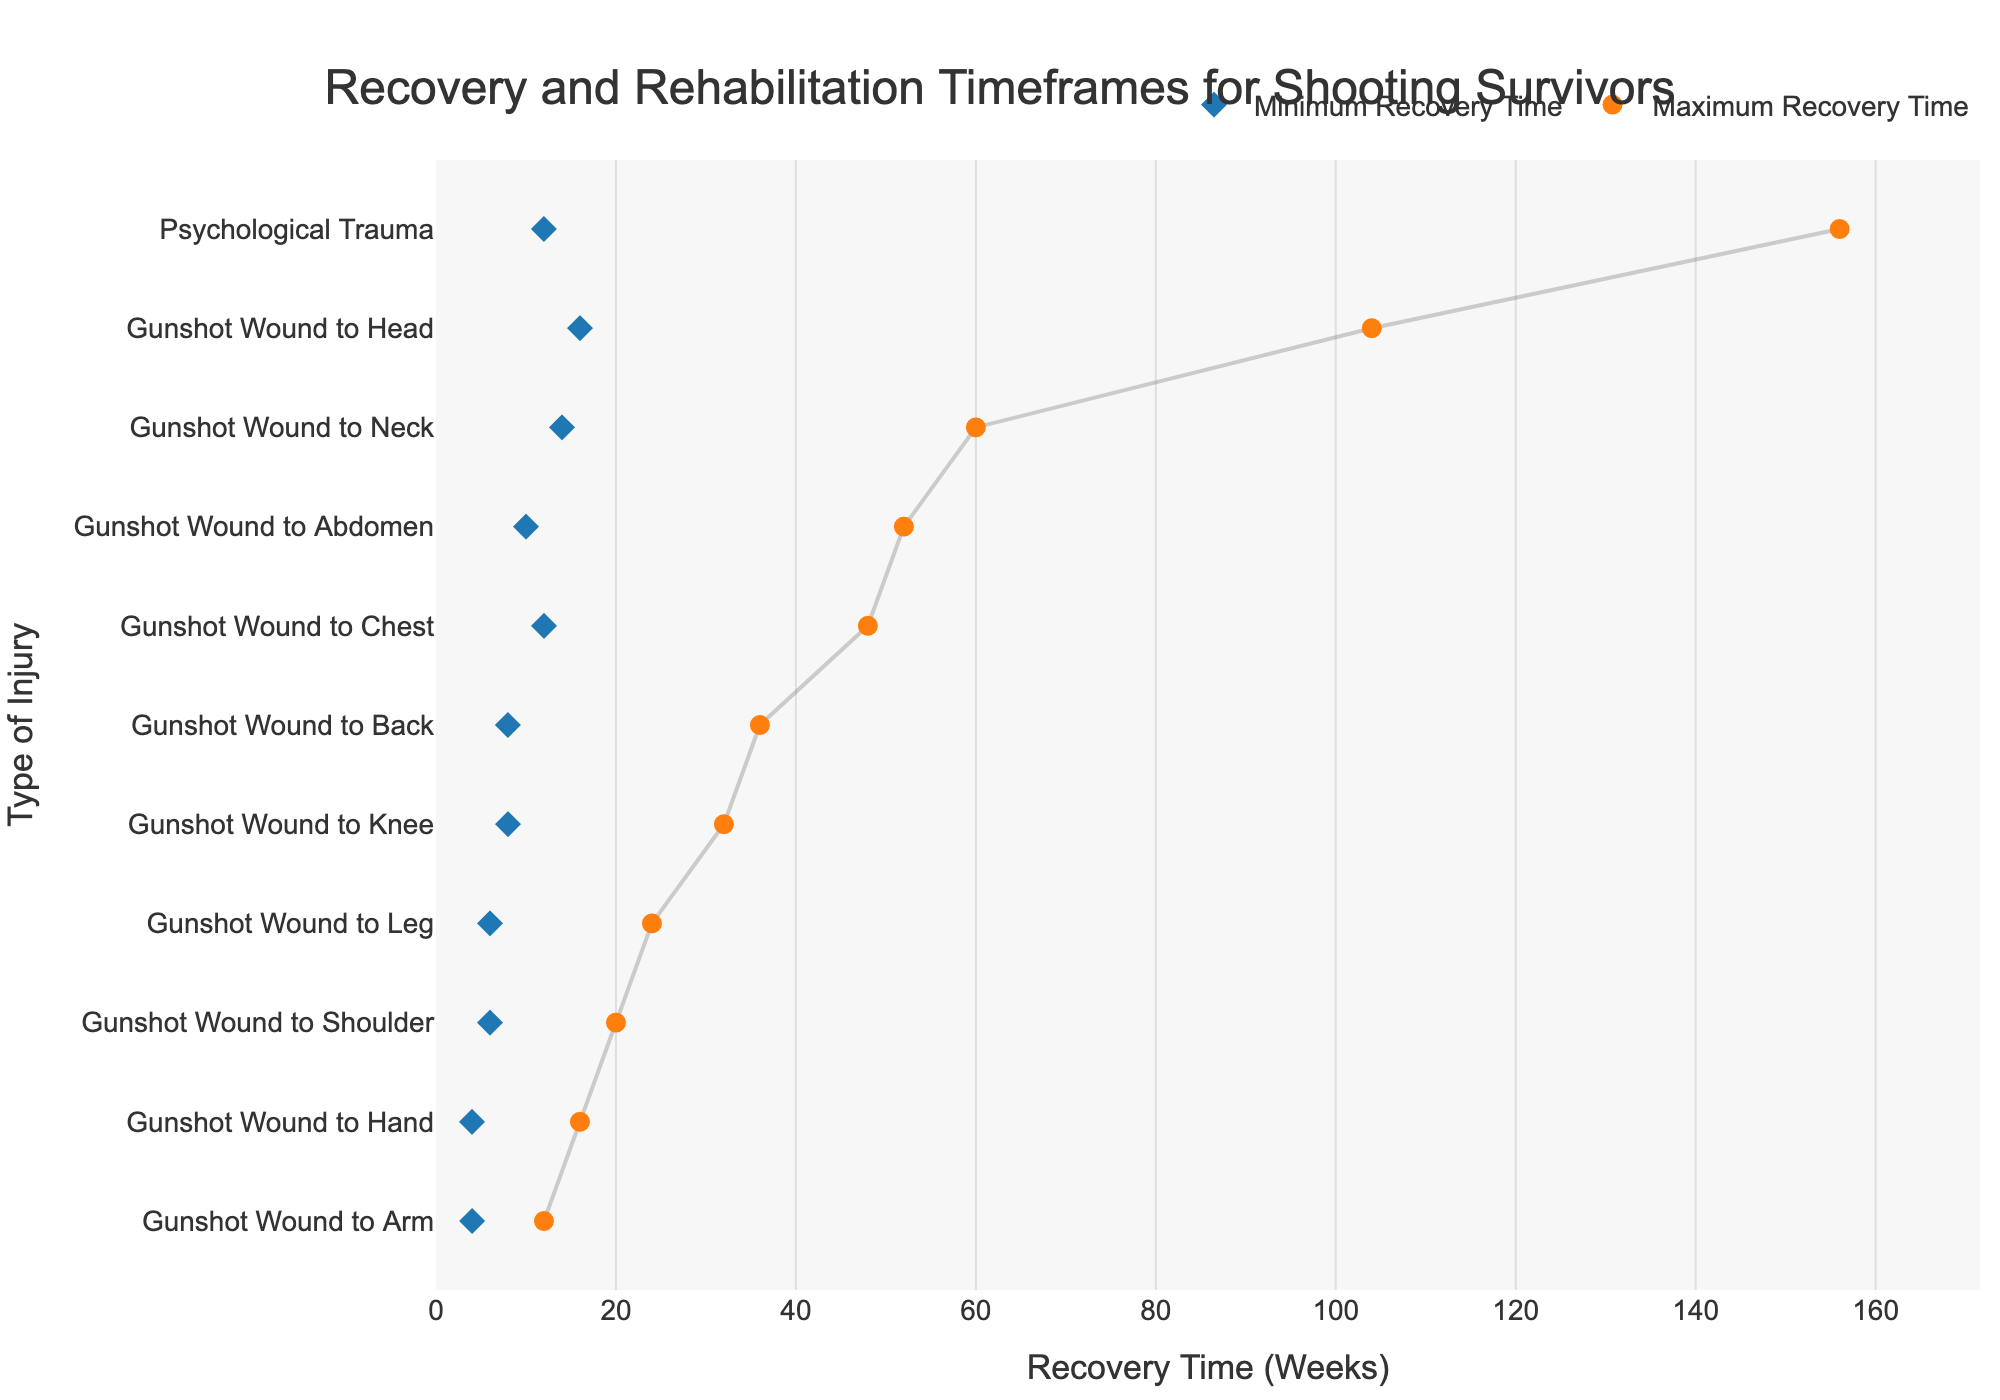What is the minimum recovery time for a gunshot wound to the head? The dot representing the minimum recovery time for a gunshot wound to the head is located at 16 weeks on the x-axis.
Answer: 16 weeks Which type of injury has the longest maximum recovery time? The dot plot shows the maximum recovery time for each injury type. The dot furthest to the right corresponds to "Psychological Trauma" with a maximum recovery time of 156 weeks.
Answer: Psychological trauma What is the range of recovery time for a gunshot wound to the abdomen? The plot uses lines to represent the range between minimum and maximum recovery times. For a gunshot wound to the abdomen, the line spans from 10 weeks to 52 weeks.
Answer: 10 to 52 weeks How does the maximum recovery time for a gunshot wound to the chest compare to a gunshot wound to the abdomen? The maximum recovery time for a gunshot wound to the chest is 48 weeks, while it is 52 weeks for a gunshot wound to the abdomen.
Answer: Chest: 48 weeks; Abdomen: 52 weeks Which type of injury has the shortest minimum recovery time? The dot closest to the zero mark on the x-axis shows the shortest minimum recovery time, which is for a gunshot wound to the arm at 4 weeks.
Answer: Gunshot wound to arm What is the average maximum recovery time for all the listed injuries? To find the average maximum recovery time, sum all the maximum recovery times and divide by the number of injury types. The sum is 560 and there are 11 injuries, so the average is 560 / 11 = 50.91 weeks.
Answer: Approximately, 51 weeks For which injuries do the minimum and maximum recovery times differ by more than 40 weeks? Calculate the difference between the minimum and maximum recovery times for each injury. Differences greater than 40 weeks are for the head (88 weeks), neck (46 weeks), chest (36 weeks), abdomen (42 weeks), and psychological trauma (144 weeks).
Answer: Head, neck, abdomen, and psychological trauma Which injury shows the smallest range between minimum and maximum recovery times? The injury with the shortest line between its minimum and maximum dots represents the smallest range. This is the gunshot wound to the arm, with a range of 8 weeks (12 - 4).
Answer: Gunshot wound to arm What is the median maximum recovery time for all injuries? Ordering the maximum recovery times, the middle value (the 6th one in a list of 11) is 36 weeks for a gunshot wound to the back.
Answer: 36 weeks 